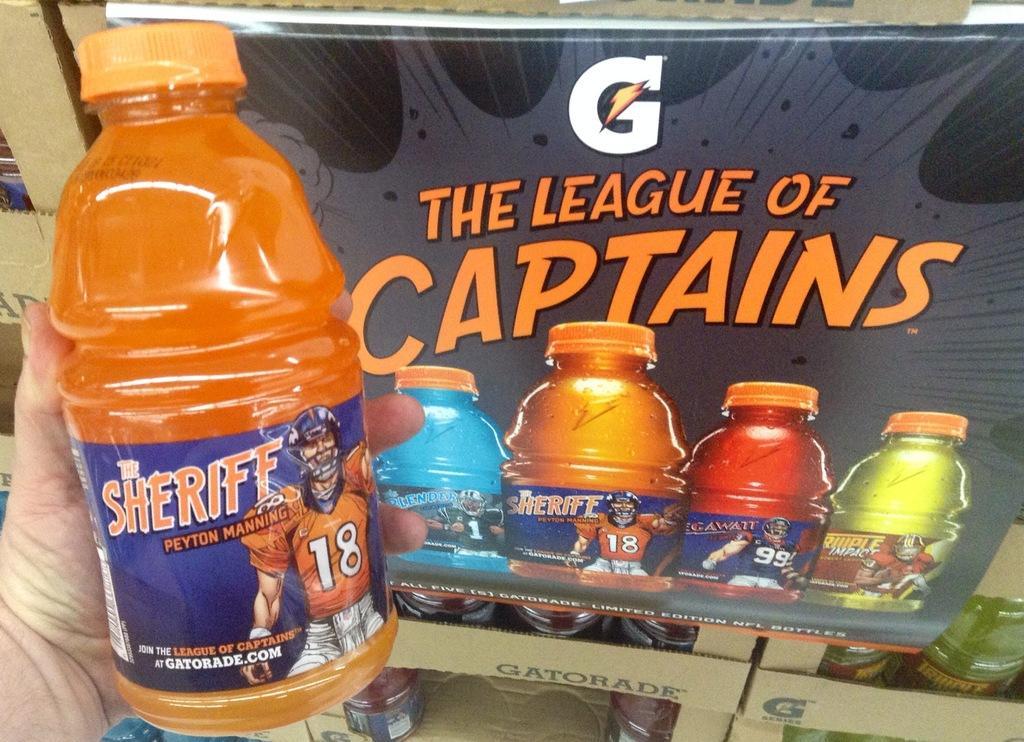In one or two sentences, can you explain what this image depicts? In image we have a bottle holding by a person in his hand. On the right side we have a board. On the board we have couple of bottles which is painted on it. 